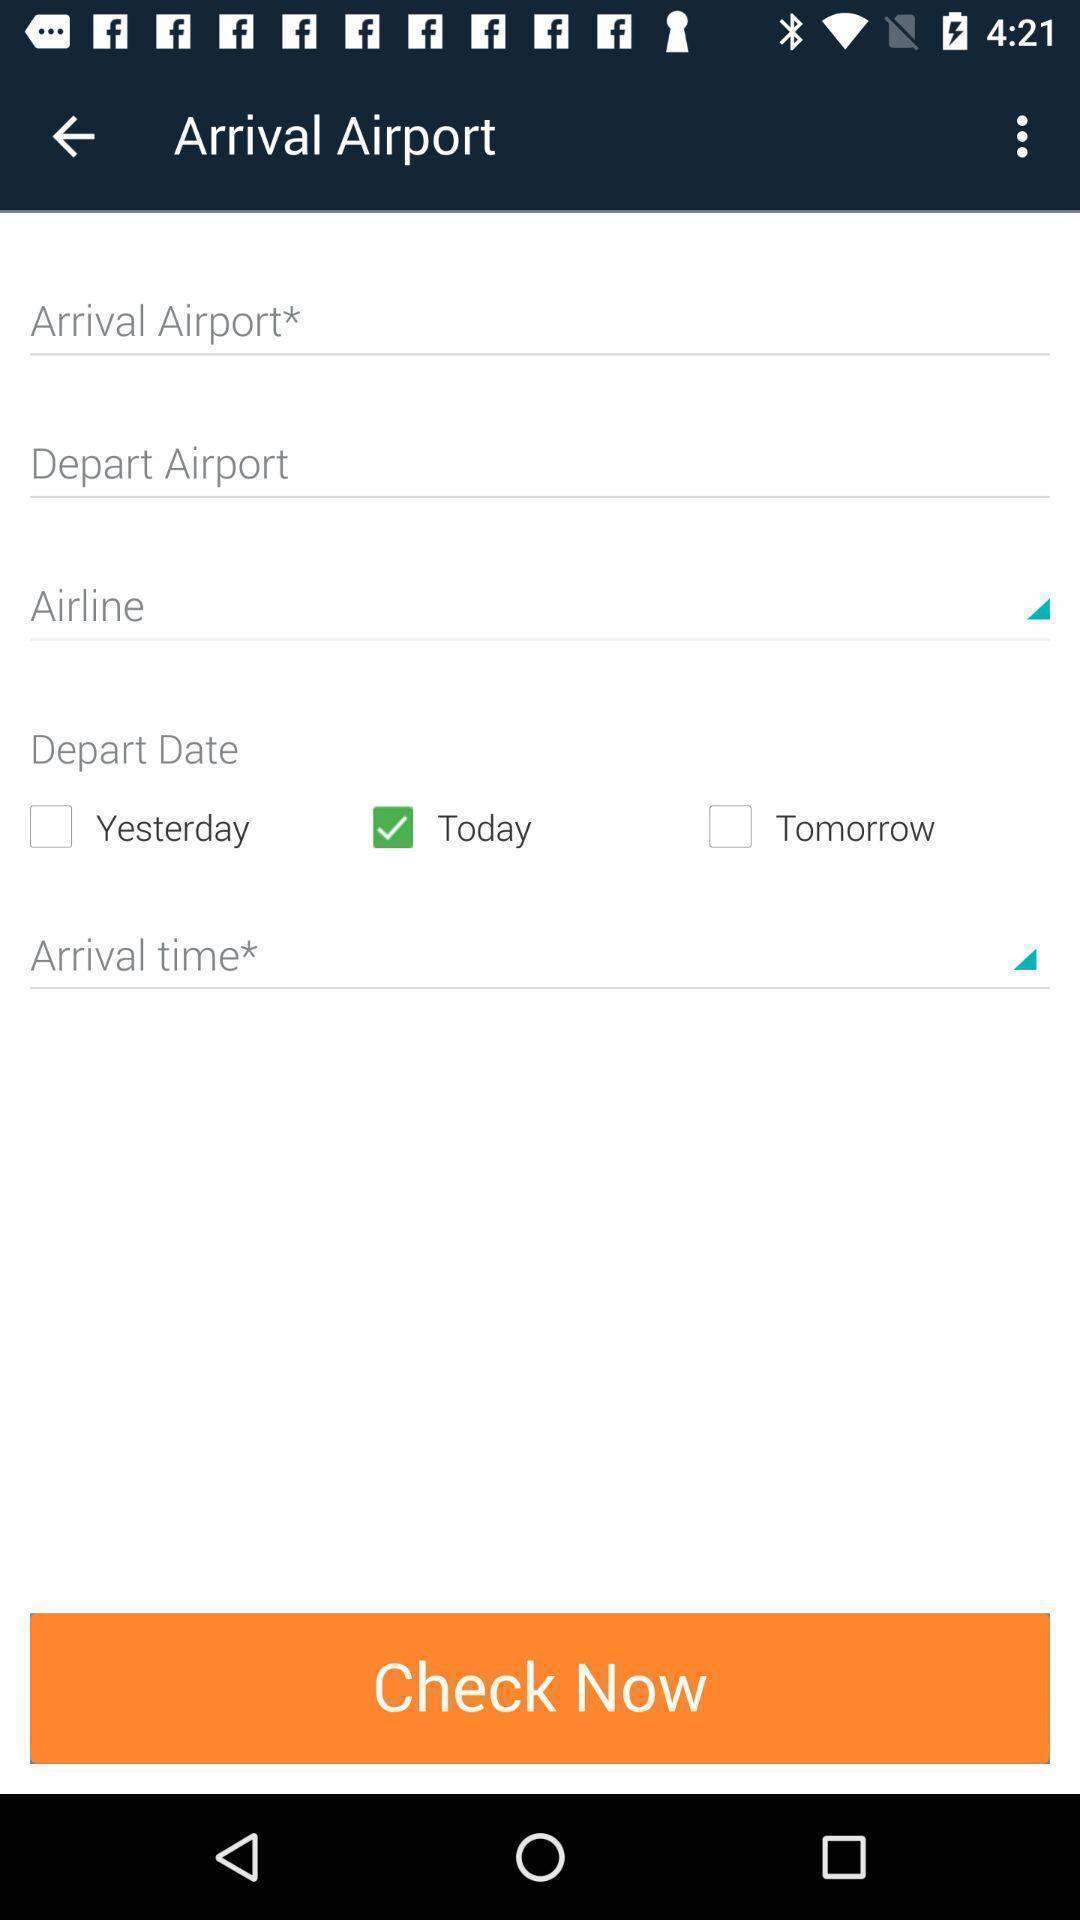Explain the elements present in this screenshot. Page shows to check arrival information of the flights. 